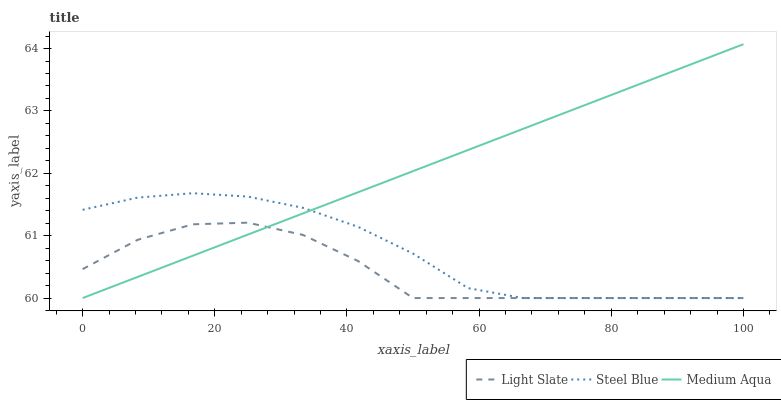Does Light Slate have the minimum area under the curve?
Answer yes or no. Yes. Does Medium Aqua have the maximum area under the curve?
Answer yes or no. Yes. Does Steel Blue have the minimum area under the curve?
Answer yes or no. No. Does Steel Blue have the maximum area under the curve?
Answer yes or no. No. Is Medium Aqua the smoothest?
Answer yes or no. Yes. Is Light Slate the roughest?
Answer yes or no. Yes. Is Steel Blue the smoothest?
Answer yes or no. No. Is Steel Blue the roughest?
Answer yes or no. No. Does Steel Blue have the highest value?
Answer yes or no. No. 